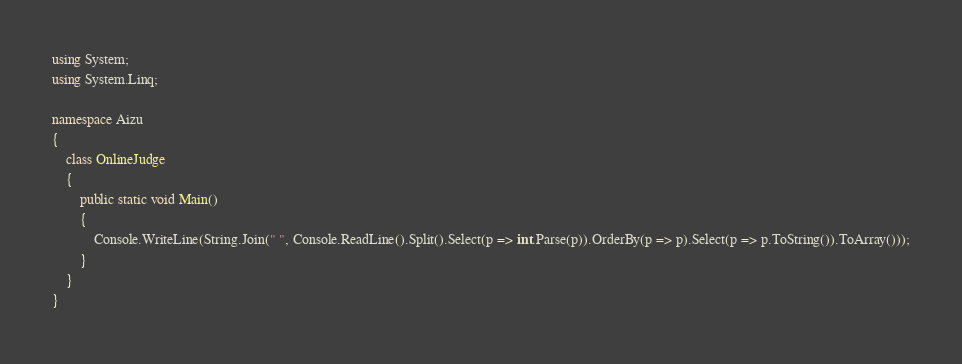Convert code to text. <code><loc_0><loc_0><loc_500><loc_500><_C#_>using System;
using System.Linq;

namespace Aizu
{
    class OnlineJudge
    {
        public static void Main()
        {
            Console.WriteLine(String.Join(" ", Console.ReadLine().Split().Select(p => int.Parse(p)).OrderBy(p => p).Select(p => p.ToString()).ToArray()));
        }
    }
}</code> 